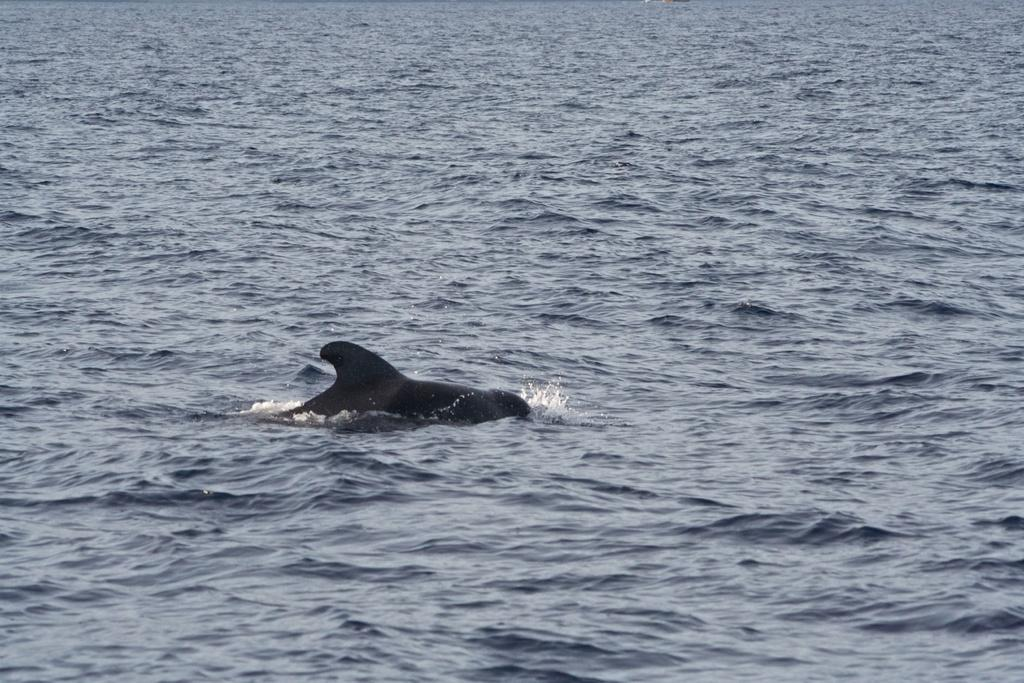What type of animal is in the image? There is a fish in the image. Where is the fish located? The fish is in the sea. Is there a bridge visible in the image? No, there is no bridge present in the image. 